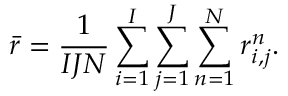Convert formula to latex. <formula><loc_0><loc_0><loc_500><loc_500>\bar { r } = \frac { 1 } { I J N } \sum _ { i = 1 } ^ { I } \sum _ { j = 1 } ^ { J } \sum _ { n = 1 } ^ { N } r _ { i , j } ^ { n } .</formula> 